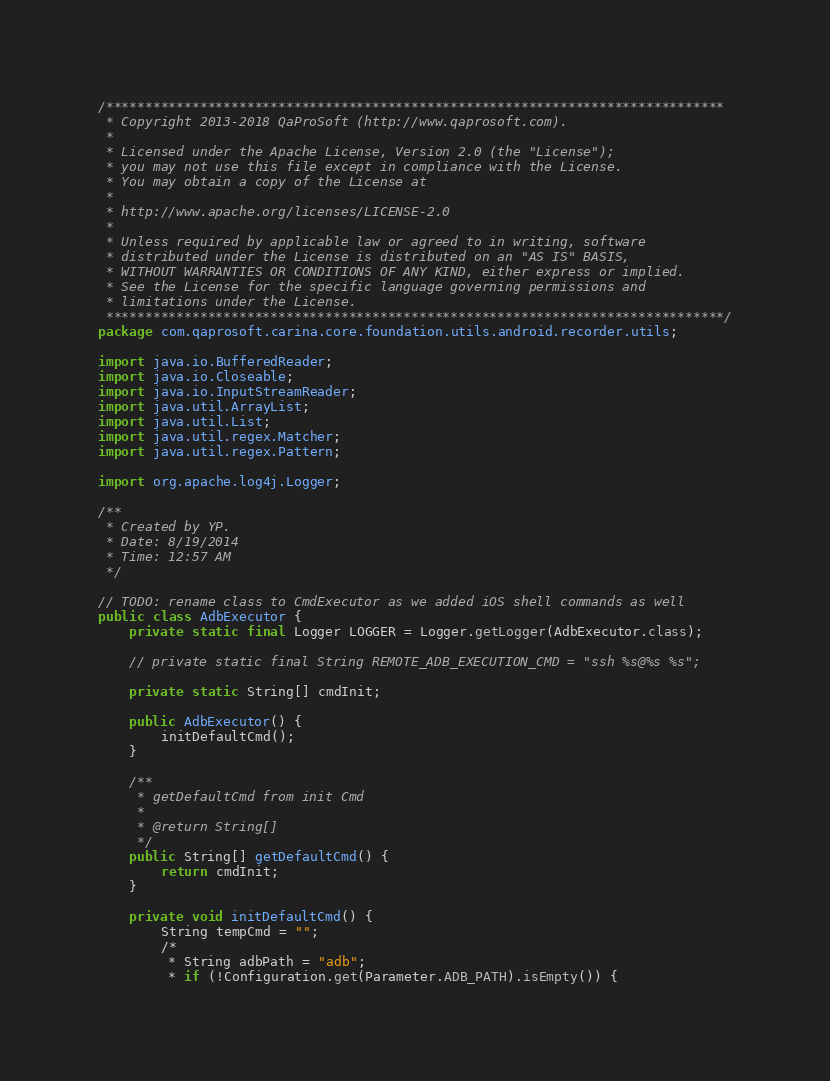Convert code to text. <code><loc_0><loc_0><loc_500><loc_500><_Java_>/*******************************************************************************
 * Copyright 2013-2018 QaProSoft (http://www.qaprosoft.com).
 *
 * Licensed under the Apache License, Version 2.0 (the "License");
 * you may not use this file except in compliance with the License.
 * You may obtain a copy of the License at
 *
 * http://www.apache.org/licenses/LICENSE-2.0
 *
 * Unless required by applicable law or agreed to in writing, software
 * distributed under the License is distributed on an "AS IS" BASIS,
 * WITHOUT WARRANTIES OR CONDITIONS OF ANY KIND, either express or implied.
 * See the License for the specific language governing permissions and
 * limitations under the License.
 *******************************************************************************/
package com.qaprosoft.carina.core.foundation.utils.android.recorder.utils;

import java.io.BufferedReader;
import java.io.Closeable;
import java.io.InputStreamReader;
import java.util.ArrayList;
import java.util.List;
import java.util.regex.Matcher;
import java.util.regex.Pattern;

import org.apache.log4j.Logger;

/**
 * Created by YP.
 * Date: 8/19/2014
 * Time: 12:57 AM
 */

// TODO: rename class to CmdExecutor as we added iOS shell commands as well
public class AdbExecutor {
    private static final Logger LOGGER = Logger.getLogger(AdbExecutor.class);

    // private static final String REMOTE_ADB_EXECUTION_CMD = "ssh %s@%s %s";

    private static String[] cmdInit;

    public AdbExecutor() {
        initDefaultCmd();
    }

    /**
     * getDefaultCmd from init Cmd
     * 
     * @return String[]
     */
    public String[] getDefaultCmd() {
        return cmdInit;
    }

    private void initDefaultCmd() {
        String tempCmd = "";
        /*
         * String adbPath = "adb";
         * if (!Configuration.get(Parameter.ADB_PATH).isEmpty()) {</code> 